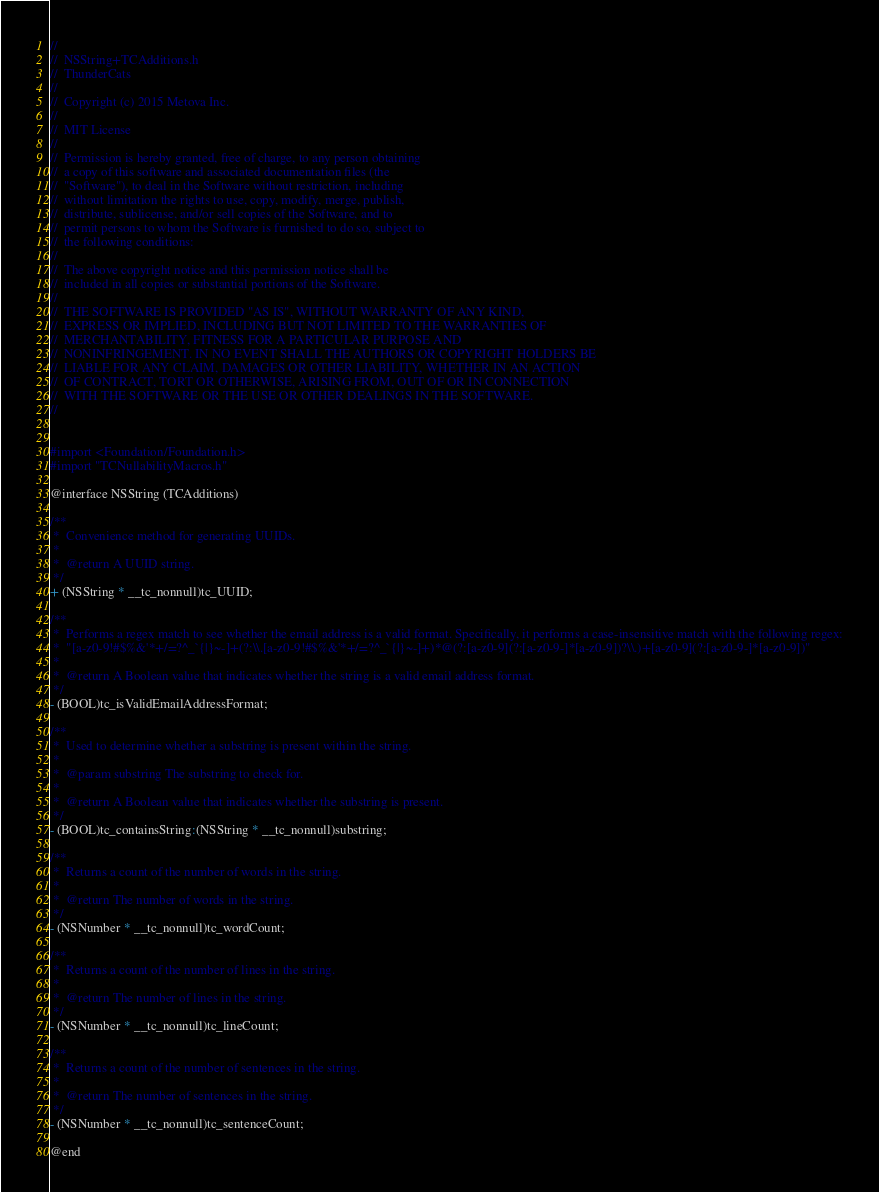Convert code to text. <code><loc_0><loc_0><loc_500><loc_500><_C_>//
//  NSString+TCAdditions.h
//  ThunderCats
//
//  Copyright (c) 2015 Metova Inc.
//
//  MIT License
//
//  Permission is hereby granted, free of charge, to any person obtaining
//  a copy of this software and associated documentation files (the
//  "Software"), to deal in the Software without restriction, including
//  without limitation the rights to use, copy, modify, merge, publish,
//  distribute, sublicense, and/or sell copies of the Software, and to
//  permit persons to whom the Software is furnished to do so, subject to
//  the following conditions:
//
//  The above copyright notice and this permission notice shall be
//  included in all copies or substantial portions of the Software.
//
//  THE SOFTWARE IS PROVIDED "AS IS", WITHOUT WARRANTY OF ANY KIND,
//  EXPRESS OR IMPLIED, INCLUDING BUT NOT LIMITED TO THE WARRANTIES OF
//  MERCHANTABILITY, FITNESS FOR A PARTICULAR PURPOSE AND
//  NONINFRINGEMENT. IN NO EVENT SHALL THE AUTHORS OR COPYRIGHT HOLDERS BE
//  LIABLE FOR ANY CLAIM, DAMAGES OR OTHER LIABILITY, WHETHER IN AN ACTION
//  OF CONTRACT, TORT OR OTHERWISE, ARISING FROM, OUT OF OR IN CONNECTION
//  WITH THE SOFTWARE OR THE USE OR OTHER DEALINGS IN THE SOFTWARE.
//


#import <Foundation/Foundation.h>
#import "TCNullabilityMacros.h"

@interface NSString (TCAdditions)

/**
 *  Convenience method for generating UUIDs.
 *
 *  @return A UUID string.
 */
+ (NSString * __tc_nonnull)tc_UUID;

/**
 *  Performs a regex match to see whether the email address is a valid format. Specifically, it performs a case-insensitive match with the following regex:
 *  "[a-z0-9!#$%&'*+/=?^_`{|}~-]+(?:\\.[a-z0-9!#$%&'*+/=?^_`{|}~-]+)*@(?:[a-z0-9](?:[a-z0-9-]*[a-z0-9])?\\.)+[a-z0-9](?:[a-z0-9-]*[a-z0-9])"
 *
 *  @return A Boolean value that indicates whether the string is a valid email address format.
 */
- (BOOL)tc_isValidEmailAddressFormat;

/**
 *  Used to determine whether a substring is present within the string.
 *
 *  @param substring The substring to check for.
 *
 *  @return A Boolean value that indicates whether the substring is present.
 */
- (BOOL)tc_containsString:(NSString * __tc_nonnull)substring;

/**
 *  Returns a count of the number of words in the string.
 *
 *  @return The number of words in the string.
 */
- (NSNumber * __tc_nonnull)tc_wordCount;

/**
 *  Returns a count of the number of lines in the string.
 *
 *  @return The number of lines in the string.
 */
- (NSNumber * __tc_nonnull)tc_lineCount;

/**
 *  Returns a count of the number of sentences in the string.
 *
 *  @return The number of sentences in the string.
 */
- (NSNumber * __tc_nonnull)tc_sentenceCount;

@end
</code> 